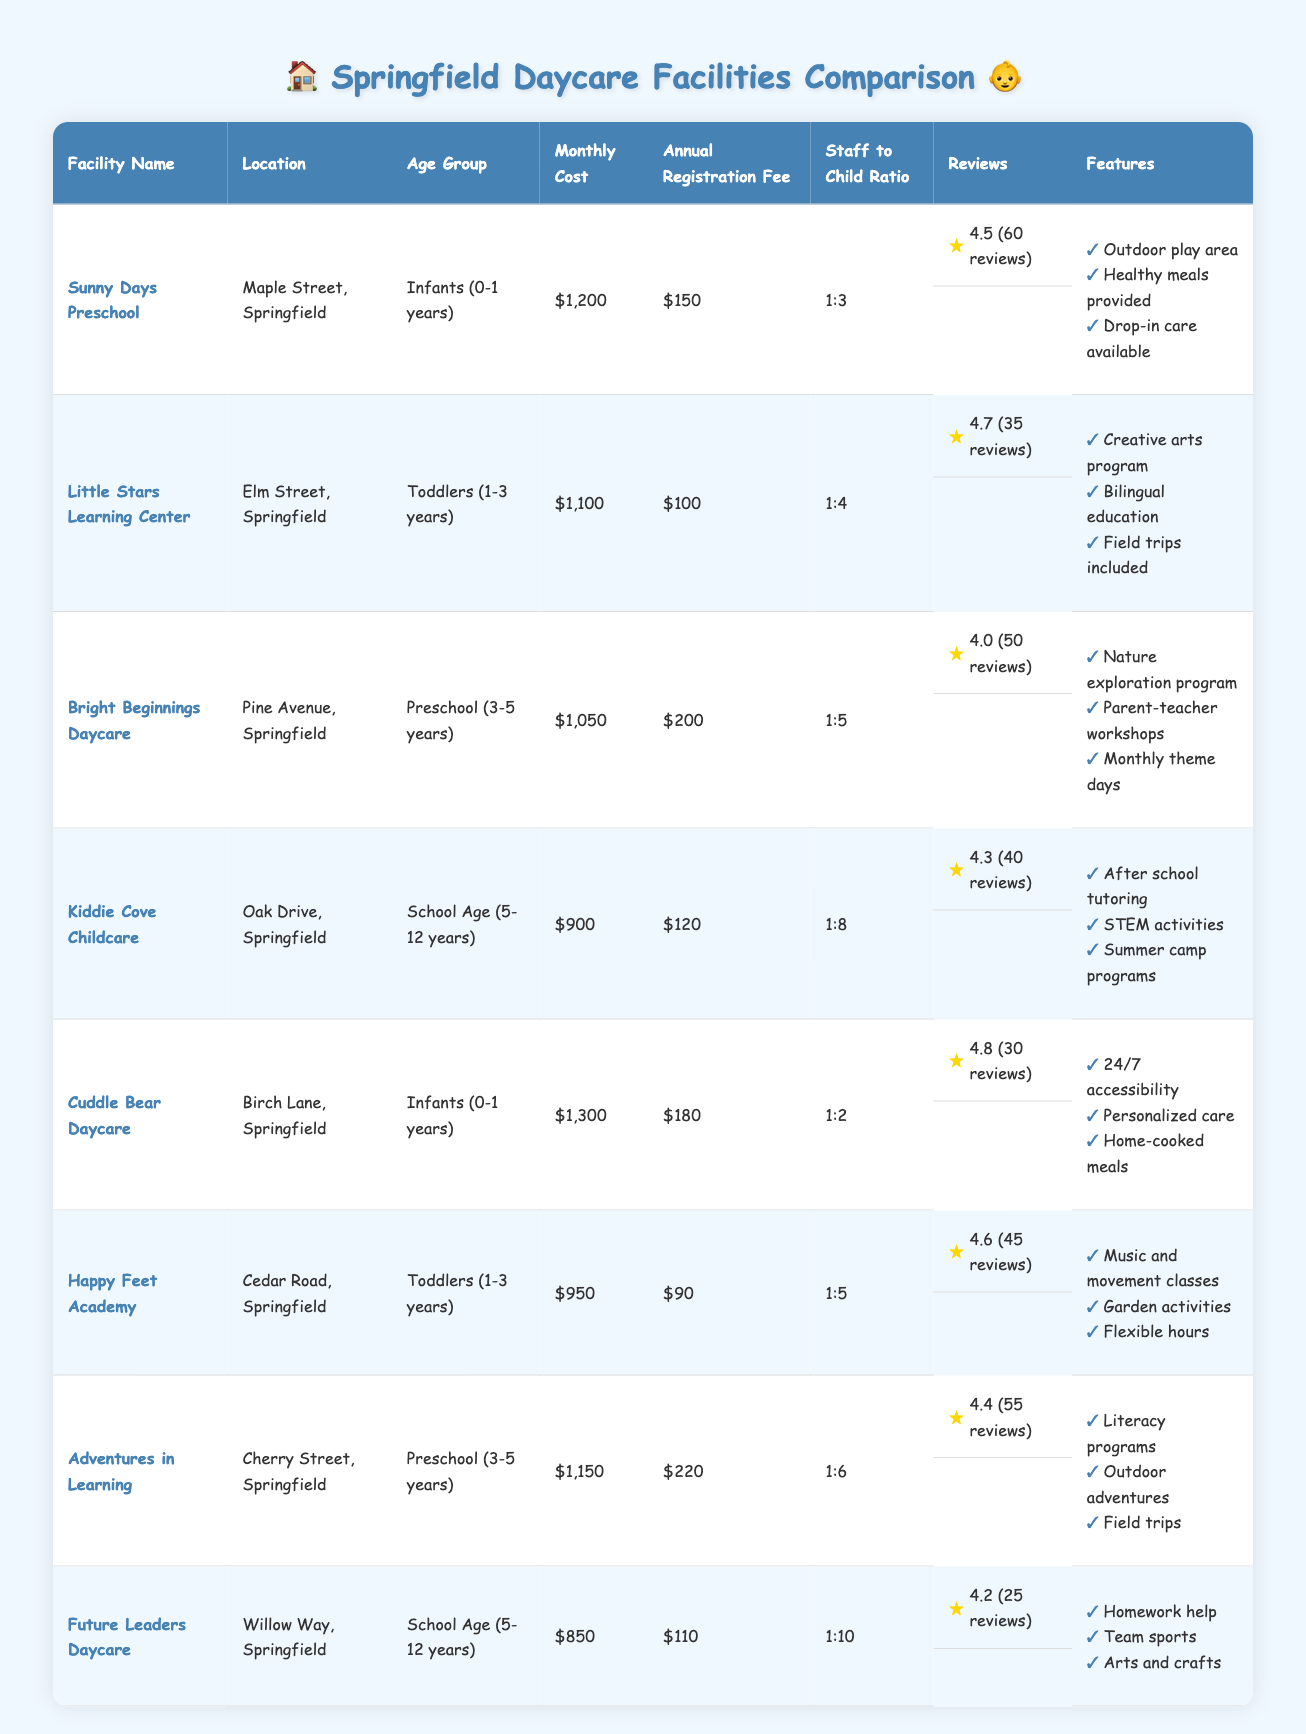What is the monthly cost for Cuddle Bear Daycare? According to the table, the monthly cost for Cuddle Bear Daycare is listed as $1,300.
Answer: $1,300 Which facility has the lowest monthly cost? The table shows that Future Leaders Daycare has the lowest monthly cost of $850 compared to other facilities.
Answer: Future Leaders Daycare What is the staff-to-child ratio for Bright Beginnings Daycare? The table states that the staff-to-child ratio for Bright Beginnings Daycare is 1:5.
Answer: 1:5 How much is the annual registration fee for Happy Feet Academy? The annual registration fee for Happy Feet Academy is $90, as indicated in the table.
Answer: $90 Does Little Stars Learning Center offer drop-in care? The features listed for Little Stars Learning Center do not mention drop-in care, which is indicated for Sunny Days Preschool.
Answer: No Which facility has the highest rating? Cuddle Bear Daycare has the highest rating of 4.8 according to the reviews section of the table.
Answer: Cuddle Bear Daycare What is the average monthly cost for all the facilities? The monthly costs are $1,200 (Sunny Days) + $1,100 (Little Stars) + $1,050 (Bright Beginnings) + $900 (Kiddie Cove) + $1,300 (Cuddle Bear) + $950 (Happy Feet) + $1,150 (Adventures in Learning) + $850 (Future Leaders). The total is $8,500. There are 8 facilities, so the average monthly cost is $8,500 / 8 = $1,062.50.
Answer: $1,062.50 Compare the staff-to-child ratios of Infants and Toddlers facilities. For Infants, Sunny Days Preschool has a ratio of 1:3 and Cuddle Bear Daycare has 1:2, which averages to (1/3 + 1/2) / 2 = 5/6 or 1:2.5. For Toddlers, Little Stars Learning Center has 1:4 and Happy Feet Academy has 1:5, which averages to (1/4 + 1/5) / 2 = 9/20 or 1:2.22. The Infants have a lower ratio indicating more care per child.
Answer: Infants have a better ratio What unique features does Adventures in Learning have compared to other facilities? Adventures in Learning offers literacy programs, outdoor adventures, and field trips, which are distinct from features provided by other facilities listed in the table.
Answer: Unique features include literacy programs and outdoor adventures Which daycare facility for School Age children is the most affordable? The table shows that Future Leaders Daycare at $850 monthly is the most affordable for School Age children, compared to Kiddie Cove which costs $900.
Answer: Future Leaders Daycare How many reviews does Sunny Days Preschool have? According to the reviews section, Sunny Days Preschool has received 60 reviews.
Answer: 60 reviews 